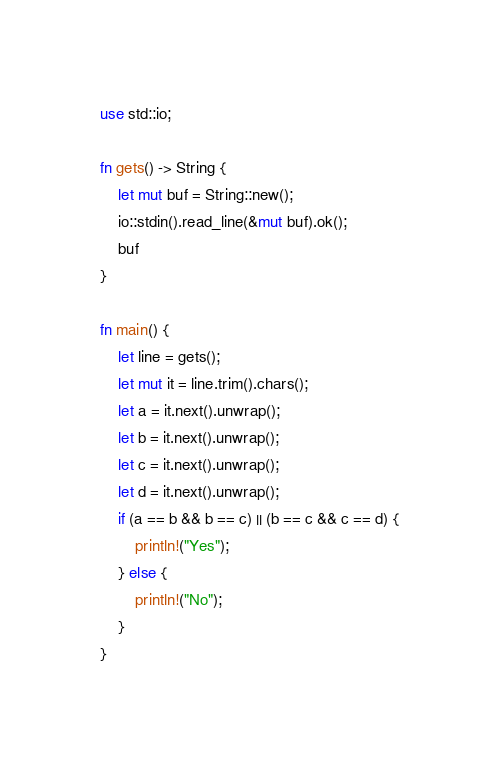<code> <loc_0><loc_0><loc_500><loc_500><_Rust_>use std::io;

fn gets() -> String {
    let mut buf = String::new();
    io::stdin().read_line(&mut buf).ok();
    buf
}

fn main() {
    let line = gets();
    let mut it = line.trim().chars();
    let a = it.next().unwrap();
    let b = it.next().unwrap();
    let c = it.next().unwrap();
    let d = it.next().unwrap();
    if (a == b && b == c) || (b == c && c == d) {
        println!("Yes");
    } else {
        println!("No");
    }
}
</code> 